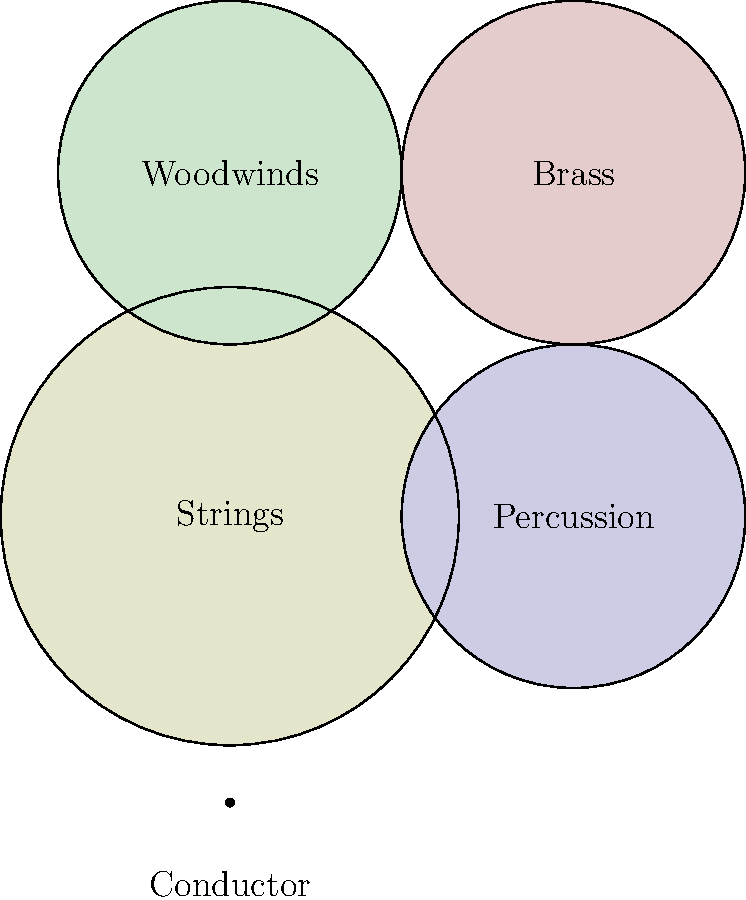As a veteran composer and arranger, you are tasked with creating a new symphonic work that highlights the unique timbral qualities of each orchestral section. Based on the seating chart diagram, which section would you position closest to the audience to emphasize its prominence in your composition, and why might this placement be advantageous for achieving a specific musical effect? To answer this question, let's analyze the seating chart and consider the musical implications:

1. The diagram shows a typical symphony orchestra layout with four main sections: Strings, Woodwinds, Brass, and Percussion.

2. The Strings section is positioned at the front, closest to the conductor and the audience.

3. This placement of the Strings section is advantageous for several reasons:
   a) Strings have a wide dynamic range and can play very softly, so placing them in front allows their nuanced sounds to be heard clearly.
   b) String instruments project sound upward and forward, making front placement ideal for audience reception.
   c) Strings often carry the main melodic lines and harmonic foundation in orchestral works, so their prominence is crucial.

4. As a composer focusing on timbral qualities:
   a) The front placement of strings allows for intricate textures and subtle harmonies to be clearly audible.
   b) You can create interesting contrasts by having the strings dialogue with the woodwinds (positioned behind them) or the brass and percussion (on the sides).
   c) The strings' position enables you to exploit their full dynamic range, from pianissimo to fortissimo, without being overpowered by other sections.

5. This arrangement also allows for traditional orchestration techniques like:
   a) Using the strings as a foundation for other sections to build upon.
   b) Creating antiphonal effects between the strings and other sections.
   c) Gradually introducing other instrumental colors while maintaining the strings as a constant presence.

Therefore, the Strings section, being placed closest to the audience, would be the most advantageous for emphasizing prominence and achieving specific timbral effects in your composition.
Answer: Strings section 